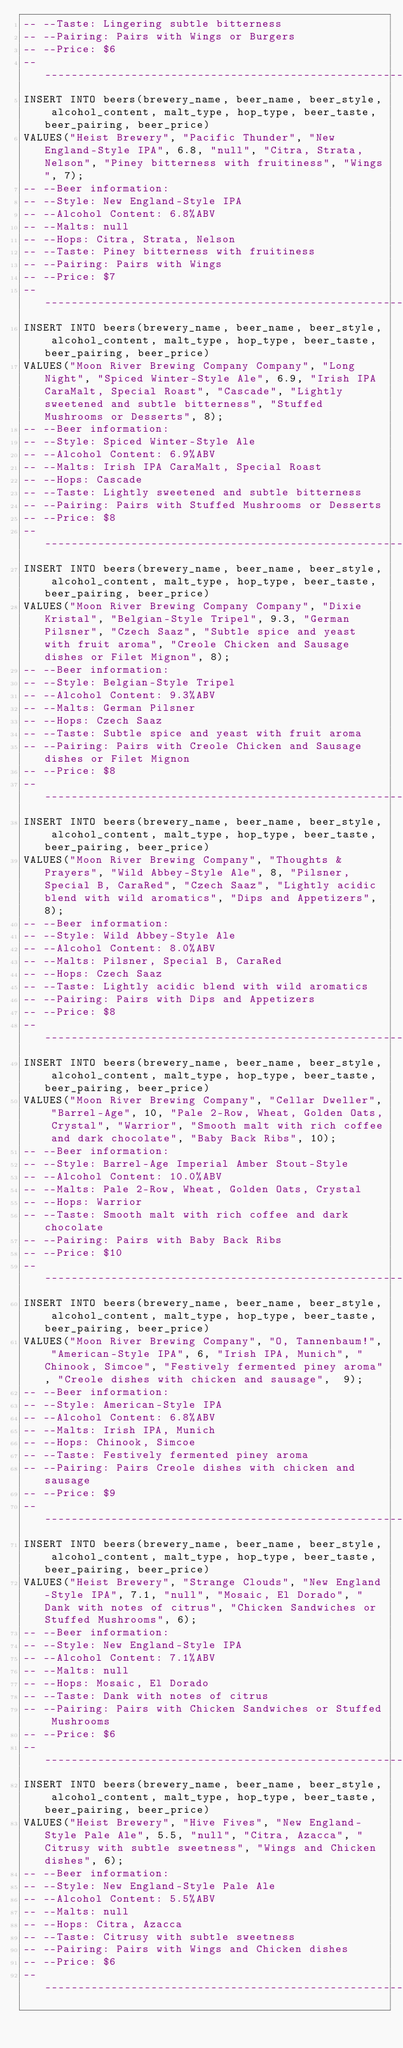Convert code to text. <code><loc_0><loc_0><loc_500><loc_500><_SQL_>-- --Taste: Lingering subtle bitterness
-- --Pairing: Pairs with Wings or Burgers
-- --Price: $6
-- ----------------------------------------------------------------
INSERT INTO beers(brewery_name, beer_name, beer_style, alcohol_content, malt_type, hop_type, beer_taste, beer_pairing, beer_price)
VALUES("Heist Brewery", "Pacific Thunder", "New England-Style IPA", 6.8, "null", "Citra, Strata, Nelson", "Piney bitterness with fruitiness", "Wings", 7);
-- --Beer information: 
-- --Style: New England-Style IPA
-- --Alcohol Content: 6.8%ABV
-- --Malts: null
-- --Hops: Citra, Strata, Nelson
-- --Taste: Piney bitterness with fruitiness
-- --Pairing: Pairs with Wings
-- --Price: $7
-- ----------------------------------------------------------------
INSERT INTO beers(brewery_name, beer_name, beer_style, alcohol_content, malt_type, hop_type, beer_taste, beer_pairing, beer_price)
VALUES("Moon River Brewing Company Company", "Long Night", "Spiced Winter-Style Ale", 6.9, "Irish IPA CaraMalt, Special Roast", "Cascade", "Lightly sweetened and subtle bitterness", "Stuffed Mushrooms or Desserts", 8);
-- --Beer information: 
-- --Style: Spiced Winter-Style Ale
-- --Alcohol Content: 6.9%ABV
-- --Malts: Irish IPA CaraMalt, Special Roast
-- --Hops: Cascade
-- --Taste: Lightly sweetened and subtle bitterness
-- --Pairing: Pairs with Stuffed Mushrooms or Desserts
-- --Price: $8
-- ----------------------------------------------------------------
INSERT INTO beers(brewery_name, beer_name, beer_style, alcohol_content, malt_type, hop_type, beer_taste, beer_pairing, beer_price)
VALUES("Moon River Brewing Company Company", "Dixie Kristal", "Belgian-Style Tripel", 9.3, "German Pilsner", "Czech Saaz", "Subtle spice and yeast with fruit aroma", "Creole Chicken and Sausage dishes or Filet Mignon", 8);
-- --Beer information: 
-- --Style: Belgian-Style Tripel
-- --Alcohol Content: 9.3%ABV
-- --Malts: German Pilsner
-- --Hops: Czech Saaz
-- --Taste: Subtle spice and yeast with fruit aroma
-- --Pairing: Pairs with Creole Chicken and Sausage dishes or Filet Mignon
-- --Price: $8
-- ----------------------------------------------------------------
INSERT INTO beers(brewery_name, beer_name, beer_style, alcohol_content, malt_type, hop_type, beer_taste, beer_pairing, beer_price)
VALUES("Moon River Brewing Company", "Thoughts & Prayers", "Wild Abbey-Style Ale", 8, "Pilsner, Special B, CaraRed", "Czech Saaz", "Lightly acidic blend with wild aromatics", "Dips and Appetizers", 8);
-- --Beer information: 
-- --Style: Wild Abbey-Style Ale
-- --Alcohol Content: 8.0%ABV
-- --Malts: Pilsner, Special B, CaraRed
-- --Hops: Czech Saaz
-- --Taste: Lightly acidic blend with wild aromatics
-- --Pairing: Pairs with Dips and Appetizers
-- --Price: $8
-- ----------------------------------------------------------------
INSERT INTO beers(brewery_name, beer_name, beer_style, alcohol_content, malt_type, hop_type, beer_taste, beer_pairing, beer_price)
VALUES("Moon River Brewing Company", "Cellar Dweller", "Barrel-Age", 10, "Pale 2-Row, Wheat, Golden Oats, Crystal", "Warrior", "Smooth malt with rich coffee and dark chocolate", "Baby Back Ribs", 10);
-- --Beer information: 
-- --Style: Barrel-Age Imperial Amber Stout-Style
-- --Alcohol Content: 10.0%ABV
-- --Malts: Pale 2-Row, Wheat, Golden Oats, Crystal
-- --Hops: Warrior
-- --Taste: Smooth malt with rich coffee and dark chocolate
-- --Pairing: Pairs with Baby Back Ribs
-- --Price: $10
-- ----------------------------------------------------------------
INSERT INTO beers(brewery_name, beer_name, beer_style, alcohol_content, malt_type, hop_type, beer_taste, beer_pairing, beer_price)
VALUES("Moon River Brewing Company", "O, Tannenbaum!", "American-Style IPA", 6, "Irish IPA, Munich", "Chinook, Simcoe", "Festively fermented piney aroma", "Creole dishes with chicken and sausage",  9);
-- --Beer information: 
-- --Style: American-Style IPA
-- --Alcohol Content: 6.8%ABV
-- --Malts: Irish IPA, Munich
-- --Hops: Chinook, Simcoe
-- --Taste: Festively fermented piney aroma
-- --Pairing: Pairs Creole dishes with chicken and sausage
-- --Price: $9
-- ----------------------------------------------------------------
INSERT INTO beers(brewery_name, beer_name, beer_style, alcohol_content, malt_type, hop_type, beer_taste, beer_pairing, beer_price)
VALUES("Heist Brewery", "Strange Clouds", "New England-Style IPA", 7.1, "null", "Mosaic, El Dorado", "Dank with notes of citrus", "Chicken Sandwiches or Stuffed Mushrooms", 6);
-- --Beer information: 
-- --Style: New England-Style IPA
-- --Alcohol Content: 7.1%ABV
-- --Malts: null
-- --Hops: Mosaic, El Dorado
-- --Taste: Dank with notes of citrus 
-- --Pairing: Pairs with Chicken Sandwiches or Stuffed Mushrooms
-- --Price: $6
-- ----------------------------------------------------------------
INSERT INTO beers(brewery_name, beer_name, beer_style, alcohol_content, malt_type, hop_type, beer_taste, beer_pairing, beer_price)
VALUES("Heist Brewery", "Hive Fives", "New England-Style Pale Ale", 5.5, "null", "Citra, Azacca", "Citrusy with subtle sweetness", "Wings and Chicken dishes", 6);
-- --Beer information: 
-- --Style: New England-Style Pale Ale
-- --Alcohol Content: 5.5%ABV
-- --Malts: null
-- --Hops: Citra, Azacca
-- --Taste: Citrusy with subtle sweetness
-- --Pairing: Pairs with Wings and Chicken dishes
-- --Price: $6
-- ----------------------------------------------------------------</code> 